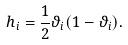<formula> <loc_0><loc_0><loc_500><loc_500>h _ { i } = \frac { 1 } { 2 } \vartheta _ { i } ( 1 - \vartheta _ { i } ) .</formula> 